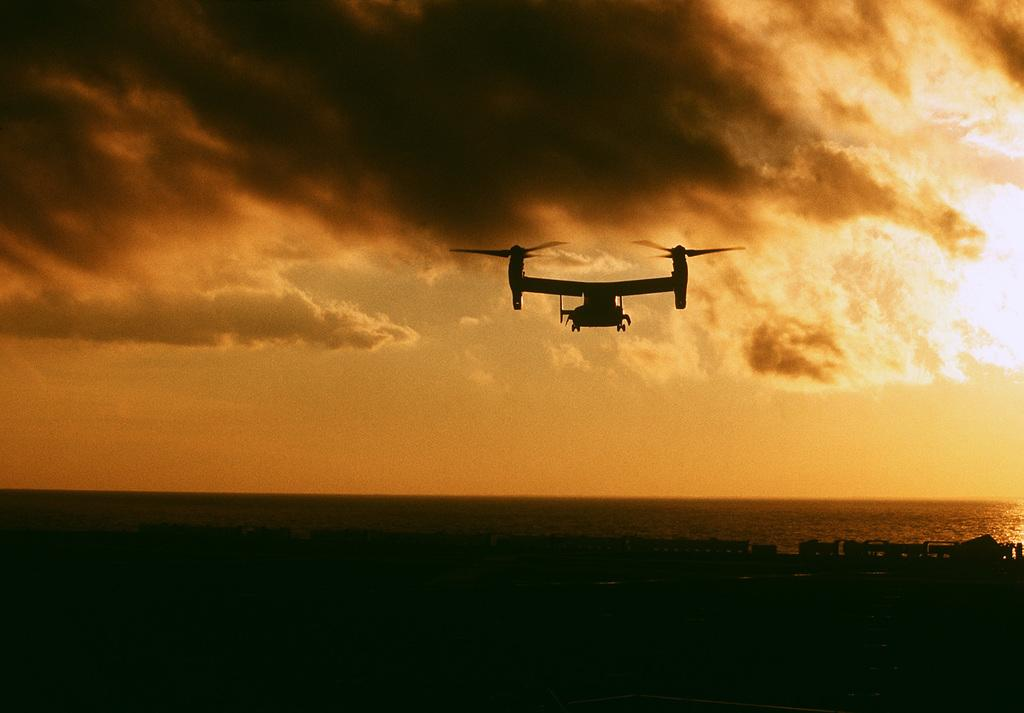What is the main subject of the image? The main subject of the image is an airplane. What is the airplane doing in the image? The airplane is flying in the sky. What can be seen in the sky besides the airplane? Clouds are visible in the sky. What else is visible in the image besides the sky? There is water visible in the image. What type of power source is used by the can in the image? There is no can present in the image, so it is not possible to determine the type of power source used. 